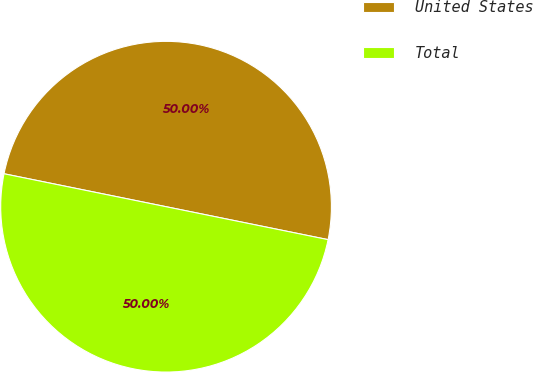Convert chart to OTSL. <chart><loc_0><loc_0><loc_500><loc_500><pie_chart><fcel>United States<fcel>Total<nl><fcel>50.0%<fcel>50.0%<nl></chart> 